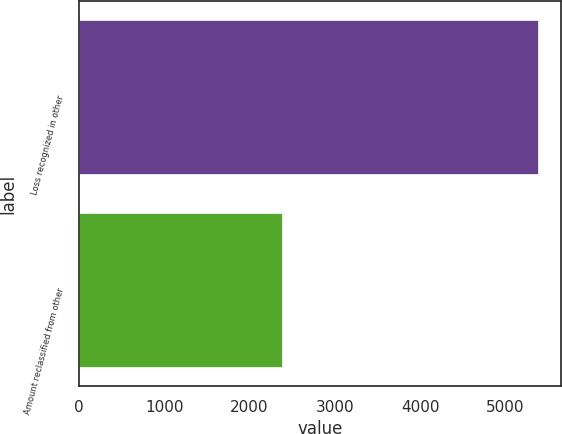Convert chart. <chart><loc_0><loc_0><loc_500><loc_500><bar_chart><fcel>Loss recognized in other<fcel>Amount reclassified from other<nl><fcel>5386<fcel>2385<nl></chart> 